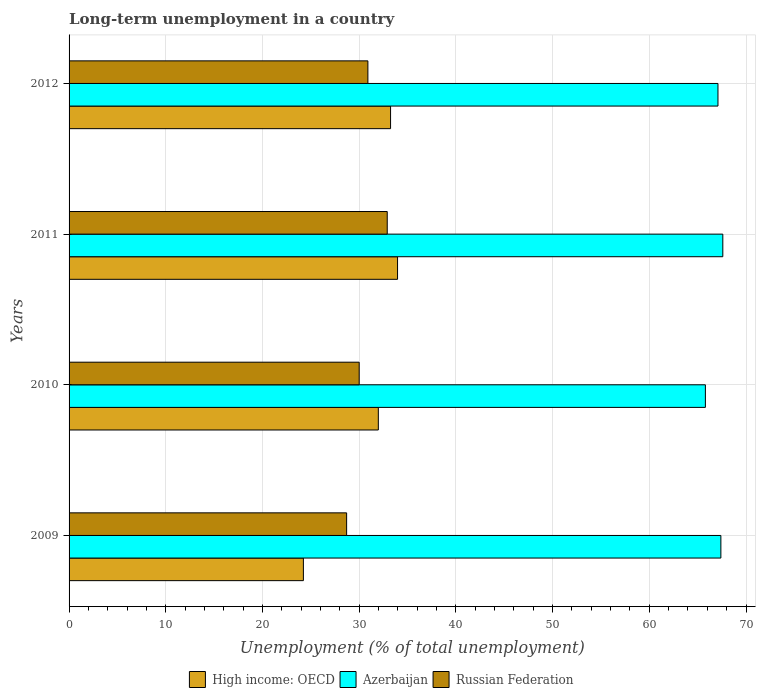Are the number of bars on each tick of the Y-axis equal?
Your response must be concise. Yes. What is the label of the 1st group of bars from the top?
Ensure brevity in your answer.  2012. What is the percentage of long-term unemployed population in Russian Federation in 2011?
Provide a short and direct response. 32.9. Across all years, what is the maximum percentage of long-term unemployed population in Azerbaijan?
Your answer should be very brief. 67.6. Across all years, what is the minimum percentage of long-term unemployed population in Azerbaijan?
Your response must be concise. 65.8. In which year was the percentage of long-term unemployed population in High income: OECD maximum?
Give a very brief answer. 2011. What is the total percentage of long-term unemployed population in Azerbaijan in the graph?
Keep it short and to the point. 267.9. What is the difference between the percentage of long-term unemployed population in High income: OECD in 2010 and that in 2011?
Provide a succinct answer. -1.99. What is the difference between the percentage of long-term unemployed population in Azerbaijan in 2009 and the percentage of long-term unemployed population in Russian Federation in 2011?
Give a very brief answer. 34.5. What is the average percentage of long-term unemployed population in Azerbaijan per year?
Your answer should be compact. 66.98. In the year 2009, what is the difference between the percentage of long-term unemployed population in Azerbaijan and percentage of long-term unemployed population in High income: OECD?
Offer a very short reply. 43.17. In how many years, is the percentage of long-term unemployed population in Russian Federation greater than 12 %?
Make the answer very short. 4. What is the ratio of the percentage of long-term unemployed population in Azerbaijan in 2009 to that in 2010?
Provide a succinct answer. 1.02. Is the percentage of long-term unemployed population in Russian Federation in 2009 less than that in 2010?
Give a very brief answer. Yes. Is the difference between the percentage of long-term unemployed population in Azerbaijan in 2009 and 2012 greater than the difference between the percentage of long-term unemployed population in High income: OECD in 2009 and 2012?
Provide a succinct answer. Yes. What is the difference between the highest and the second highest percentage of long-term unemployed population in High income: OECD?
Offer a very short reply. 0.72. What is the difference between the highest and the lowest percentage of long-term unemployed population in Azerbaijan?
Make the answer very short. 1.8. Is the sum of the percentage of long-term unemployed population in High income: OECD in 2010 and 2012 greater than the maximum percentage of long-term unemployed population in Russian Federation across all years?
Make the answer very short. Yes. What does the 2nd bar from the top in 2011 represents?
Provide a succinct answer. Azerbaijan. What does the 1st bar from the bottom in 2012 represents?
Make the answer very short. High income: OECD. How many bars are there?
Keep it short and to the point. 12. How many years are there in the graph?
Offer a terse response. 4. What is the difference between two consecutive major ticks on the X-axis?
Provide a short and direct response. 10. Are the values on the major ticks of X-axis written in scientific E-notation?
Give a very brief answer. No. Does the graph contain any zero values?
Give a very brief answer. No. Does the graph contain grids?
Provide a short and direct response. Yes. Where does the legend appear in the graph?
Your answer should be very brief. Bottom center. How many legend labels are there?
Offer a very short reply. 3. What is the title of the graph?
Offer a terse response. Long-term unemployment in a country. Does "St. Kitts and Nevis" appear as one of the legend labels in the graph?
Your response must be concise. No. What is the label or title of the X-axis?
Your answer should be compact. Unemployment (% of total unemployment). What is the label or title of the Y-axis?
Your answer should be very brief. Years. What is the Unemployment (% of total unemployment) in High income: OECD in 2009?
Your answer should be compact. 24.23. What is the Unemployment (% of total unemployment) of Azerbaijan in 2009?
Provide a short and direct response. 67.4. What is the Unemployment (% of total unemployment) in Russian Federation in 2009?
Provide a short and direct response. 28.7. What is the Unemployment (% of total unemployment) of High income: OECD in 2010?
Your response must be concise. 31.98. What is the Unemployment (% of total unemployment) in Azerbaijan in 2010?
Offer a terse response. 65.8. What is the Unemployment (% of total unemployment) in High income: OECD in 2011?
Make the answer very short. 33.97. What is the Unemployment (% of total unemployment) in Azerbaijan in 2011?
Your answer should be very brief. 67.6. What is the Unemployment (% of total unemployment) of Russian Federation in 2011?
Your response must be concise. 32.9. What is the Unemployment (% of total unemployment) in High income: OECD in 2012?
Your response must be concise. 33.24. What is the Unemployment (% of total unemployment) in Azerbaijan in 2012?
Give a very brief answer. 67.1. What is the Unemployment (% of total unemployment) of Russian Federation in 2012?
Keep it short and to the point. 30.9. Across all years, what is the maximum Unemployment (% of total unemployment) in High income: OECD?
Offer a very short reply. 33.97. Across all years, what is the maximum Unemployment (% of total unemployment) of Azerbaijan?
Your answer should be very brief. 67.6. Across all years, what is the maximum Unemployment (% of total unemployment) in Russian Federation?
Your answer should be compact. 32.9. Across all years, what is the minimum Unemployment (% of total unemployment) of High income: OECD?
Ensure brevity in your answer.  24.23. Across all years, what is the minimum Unemployment (% of total unemployment) in Azerbaijan?
Keep it short and to the point. 65.8. Across all years, what is the minimum Unemployment (% of total unemployment) of Russian Federation?
Your answer should be very brief. 28.7. What is the total Unemployment (% of total unemployment) of High income: OECD in the graph?
Your answer should be very brief. 123.42. What is the total Unemployment (% of total unemployment) of Azerbaijan in the graph?
Provide a short and direct response. 267.9. What is the total Unemployment (% of total unemployment) of Russian Federation in the graph?
Your answer should be very brief. 122.5. What is the difference between the Unemployment (% of total unemployment) of High income: OECD in 2009 and that in 2010?
Give a very brief answer. -7.75. What is the difference between the Unemployment (% of total unemployment) of High income: OECD in 2009 and that in 2011?
Make the answer very short. -9.74. What is the difference between the Unemployment (% of total unemployment) of Azerbaijan in 2009 and that in 2011?
Offer a terse response. -0.2. What is the difference between the Unemployment (% of total unemployment) in Russian Federation in 2009 and that in 2011?
Give a very brief answer. -4.2. What is the difference between the Unemployment (% of total unemployment) of High income: OECD in 2009 and that in 2012?
Provide a short and direct response. -9.01. What is the difference between the Unemployment (% of total unemployment) in High income: OECD in 2010 and that in 2011?
Make the answer very short. -1.99. What is the difference between the Unemployment (% of total unemployment) of Russian Federation in 2010 and that in 2011?
Your response must be concise. -2.9. What is the difference between the Unemployment (% of total unemployment) in High income: OECD in 2010 and that in 2012?
Keep it short and to the point. -1.26. What is the difference between the Unemployment (% of total unemployment) in Azerbaijan in 2010 and that in 2012?
Give a very brief answer. -1.3. What is the difference between the Unemployment (% of total unemployment) of Russian Federation in 2010 and that in 2012?
Provide a short and direct response. -0.9. What is the difference between the Unemployment (% of total unemployment) in High income: OECD in 2011 and that in 2012?
Offer a very short reply. 0.72. What is the difference between the Unemployment (% of total unemployment) of High income: OECD in 2009 and the Unemployment (% of total unemployment) of Azerbaijan in 2010?
Offer a very short reply. -41.57. What is the difference between the Unemployment (% of total unemployment) in High income: OECD in 2009 and the Unemployment (% of total unemployment) in Russian Federation in 2010?
Provide a short and direct response. -5.77. What is the difference between the Unemployment (% of total unemployment) of Azerbaijan in 2009 and the Unemployment (% of total unemployment) of Russian Federation in 2010?
Provide a succinct answer. 37.4. What is the difference between the Unemployment (% of total unemployment) of High income: OECD in 2009 and the Unemployment (% of total unemployment) of Azerbaijan in 2011?
Ensure brevity in your answer.  -43.37. What is the difference between the Unemployment (% of total unemployment) in High income: OECD in 2009 and the Unemployment (% of total unemployment) in Russian Federation in 2011?
Offer a very short reply. -8.67. What is the difference between the Unemployment (% of total unemployment) of Azerbaijan in 2009 and the Unemployment (% of total unemployment) of Russian Federation in 2011?
Offer a very short reply. 34.5. What is the difference between the Unemployment (% of total unemployment) of High income: OECD in 2009 and the Unemployment (% of total unemployment) of Azerbaijan in 2012?
Your answer should be very brief. -42.87. What is the difference between the Unemployment (% of total unemployment) in High income: OECD in 2009 and the Unemployment (% of total unemployment) in Russian Federation in 2012?
Provide a short and direct response. -6.67. What is the difference between the Unemployment (% of total unemployment) of Azerbaijan in 2009 and the Unemployment (% of total unemployment) of Russian Federation in 2012?
Provide a short and direct response. 36.5. What is the difference between the Unemployment (% of total unemployment) of High income: OECD in 2010 and the Unemployment (% of total unemployment) of Azerbaijan in 2011?
Provide a short and direct response. -35.62. What is the difference between the Unemployment (% of total unemployment) of High income: OECD in 2010 and the Unemployment (% of total unemployment) of Russian Federation in 2011?
Give a very brief answer. -0.92. What is the difference between the Unemployment (% of total unemployment) in Azerbaijan in 2010 and the Unemployment (% of total unemployment) in Russian Federation in 2011?
Ensure brevity in your answer.  32.9. What is the difference between the Unemployment (% of total unemployment) of High income: OECD in 2010 and the Unemployment (% of total unemployment) of Azerbaijan in 2012?
Your answer should be very brief. -35.12. What is the difference between the Unemployment (% of total unemployment) of High income: OECD in 2010 and the Unemployment (% of total unemployment) of Russian Federation in 2012?
Your answer should be very brief. 1.08. What is the difference between the Unemployment (% of total unemployment) in Azerbaijan in 2010 and the Unemployment (% of total unemployment) in Russian Federation in 2012?
Your answer should be very brief. 34.9. What is the difference between the Unemployment (% of total unemployment) in High income: OECD in 2011 and the Unemployment (% of total unemployment) in Azerbaijan in 2012?
Provide a short and direct response. -33.13. What is the difference between the Unemployment (% of total unemployment) in High income: OECD in 2011 and the Unemployment (% of total unemployment) in Russian Federation in 2012?
Provide a succinct answer. 3.07. What is the difference between the Unemployment (% of total unemployment) in Azerbaijan in 2011 and the Unemployment (% of total unemployment) in Russian Federation in 2012?
Give a very brief answer. 36.7. What is the average Unemployment (% of total unemployment) of High income: OECD per year?
Offer a very short reply. 30.85. What is the average Unemployment (% of total unemployment) of Azerbaijan per year?
Make the answer very short. 66.97. What is the average Unemployment (% of total unemployment) in Russian Federation per year?
Give a very brief answer. 30.62. In the year 2009, what is the difference between the Unemployment (% of total unemployment) of High income: OECD and Unemployment (% of total unemployment) of Azerbaijan?
Your response must be concise. -43.17. In the year 2009, what is the difference between the Unemployment (% of total unemployment) of High income: OECD and Unemployment (% of total unemployment) of Russian Federation?
Offer a very short reply. -4.47. In the year 2009, what is the difference between the Unemployment (% of total unemployment) in Azerbaijan and Unemployment (% of total unemployment) in Russian Federation?
Give a very brief answer. 38.7. In the year 2010, what is the difference between the Unemployment (% of total unemployment) in High income: OECD and Unemployment (% of total unemployment) in Azerbaijan?
Give a very brief answer. -33.82. In the year 2010, what is the difference between the Unemployment (% of total unemployment) in High income: OECD and Unemployment (% of total unemployment) in Russian Federation?
Offer a very short reply. 1.98. In the year 2010, what is the difference between the Unemployment (% of total unemployment) of Azerbaijan and Unemployment (% of total unemployment) of Russian Federation?
Your answer should be very brief. 35.8. In the year 2011, what is the difference between the Unemployment (% of total unemployment) of High income: OECD and Unemployment (% of total unemployment) of Azerbaijan?
Keep it short and to the point. -33.63. In the year 2011, what is the difference between the Unemployment (% of total unemployment) of High income: OECD and Unemployment (% of total unemployment) of Russian Federation?
Offer a terse response. 1.07. In the year 2011, what is the difference between the Unemployment (% of total unemployment) in Azerbaijan and Unemployment (% of total unemployment) in Russian Federation?
Keep it short and to the point. 34.7. In the year 2012, what is the difference between the Unemployment (% of total unemployment) of High income: OECD and Unemployment (% of total unemployment) of Azerbaijan?
Offer a very short reply. -33.86. In the year 2012, what is the difference between the Unemployment (% of total unemployment) in High income: OECD and Unemployment (% of total unemployment) in Russian Federation?
Provide a short and direct response. 2.34. In the year 2012, what is the difference between the Unemployment (% of total unemployment) in Azerbaijan and Unemployment (% of total unemployment) in Russian Federation?
Ensure brevity in your answer.  36.2. What is the ratio of the Unemployment (% of total unemployment) in High income: OECD in 2009 to that in 2010?
Give a very brief answer. 0.76. What is the ratio of the Unemployment (% of total unemployment) of Azerbaijan in 2009 to that in 2010?
Offer a terse response. 1.02. What is the ratio of the Unemployment (% of total unemployment) of Russian Federation in 2009 to that in 2010?
Offer a terse response. 0.96. What is the ratio of the Unemployment (% of total unemployment) in High income: OECD in 2009 to that in 2011?
Offer a terse response. 0.71. What is the ratio of the Unemployment (% of total unemployment) in Russian Federation in 2009 to that in 2011?
Provide a short and direct response. 0.87. What is the ratio of the Unemployment (% of total unemployment) in High income: OECD in 2009 to that in 2012?
Your response must be concise. 0.73. What is the ratio of the Unemployment (% of total unemployment) in Azerbaijan in 2009 to that in 2012?
Keep it short and to the point. 1. What is the ratio of the Unemployment (% of total unemployment) in Russian Federation in 2009 to that in 2012?
Your answer should be compact. 0.93. What is the ratio of the Unemployment (% of total unemployment) of High income: OECD in 2010 to that in 2011?
Offer a very short reply. 0.94. What is the ratio of the Unemployment (% of total unemployment) in Azerbaijan in 2010 to that in 2011?
Offer a terse response. 0.97. What is the ratio of the Unemployment (% of total unemployment) of Russian Federation in 2010 to that in 2011?
Your response must be concise. 0.91. What is the ratio of the Unemployment (% of total unemployment) in Azerbaijan in 2010 to that in 2012?
Your answer should be very brief. 0.98. What is the ratio of the Unemployment (% of total unemployment) of Russian Federation in 2010 to that in 2012?
Your answer should be compact. 0.97. What is the ratio of the Unemployment (% of total unemployment) of High income: OECD in 2011 to that in 2012?
Provide a succinct answer. 1.02. What is the ratio of the Unemployment (% of total unemployment) of Azerbaijan in 2011 to that in 2012?
Keep it short and to the point. 1.01. What is the ratio of the Unemployment (% of total unemployment) in Russian Federation in 2011 to that in 2012?
Provide a succinct answer. 1.06. What is the difference between the highest and the second highest Unemployment (% of total unemployment) of High income: OECD?
Provide a succinct answer. 0.72. What is the difference between the highest and the second highest Unemployment (% of total unemployment) in Russian Federation?
Provide a short and direct response. 2. What is the difference between the highest and the lowest Unemployment (% of total unemployment) of High income: OECD?
Offer a terse response. 9.74. What is the difference between the highest and the lowest Unemployment (% of total unemployment) of Azerbaijan?
Give a very brief answer. 1.8. 